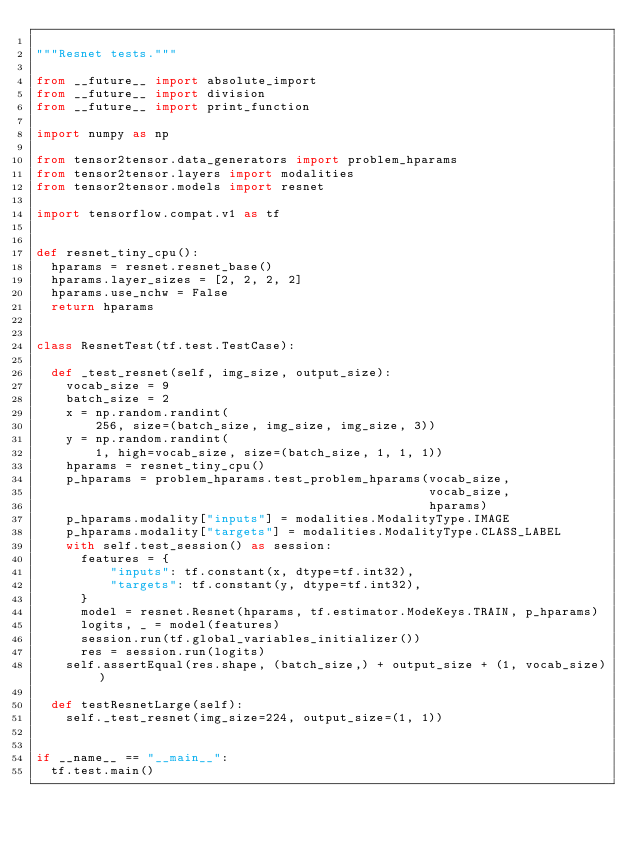Convert code to text. <code><loc_0><loc_0><loc_500><loc_500><_Python_>
"""Resnet tests."""

from __future__ import absolute_import
from __future__ import division
from __future__ import print_function

import numpy as np

from tensor2tensor.data_generators import problem_hparams
from tensor2tensor.layers import modalities
from tensor2tensor.models import resnet

import tensorflow.compat.v1 as tf


def resnet_tiny_cpu():
  hparams = resnet.resnet_base()
  hparams.layer_sizes = [2, 2, 2, 2]
  hparams.use_nchw = False
  return hparams


class ResnetTest(tf.test.TestCase):

  def _test_resnet(self, img_size, output_size):
    vocab_size = 9
    batch_size = 2
    x = np.random.randint(
        256, size=(batch_size, img_size, img_size, 3))
    y = np.random.randint(
        1, high=vocab_size, size=(batch_size, 1, 1, 1))
    hparams = resnet_tiny_cpu()
    p_hparams = problem_hparams.test_problem_hparams(vocab_size,
                                                     vocab_size,
                                                     hparams)
    p_hparams.modality["inputs"] = modalities.ModalityType.IMAGE
    p_hparams.modality["targets"] = modalities.ModalityType.CLASS_LABEL
    with self.test_session() as session:
      features = {
          "inputs": tf.constant(x, dtype=tf.int32),
          "targets": tf.constant(y, dtype=tf.int32),
      }
      model = resnet.Resnet(hparams, tf.estimator.ModeKeys.TRAIN, p_hparams)
      logits, _ = model(features)
      session.run(tf.global_variables_initializer())
      res = session.run(logits)
    self.assertEqual(res.shape, (batch_size,) + output_size + (1, vocab_size))

  def testResnetLarge(self):
    self._test_resnet(img_size=224, output_size=(1, 1))


if __name__ == "__main__":
  tf.test.main()
</code> 